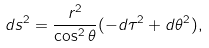Convert formula to latex. <formula><loc_0><loc_0><loc_500><loc_500>d s ^ { 2 } = \frac { r ^ { 2 } } { \cos ^ { 2 } \theta } ( - d \tau ^ { 2 } + d \theta ^ { 2 } ) ,</formula> 